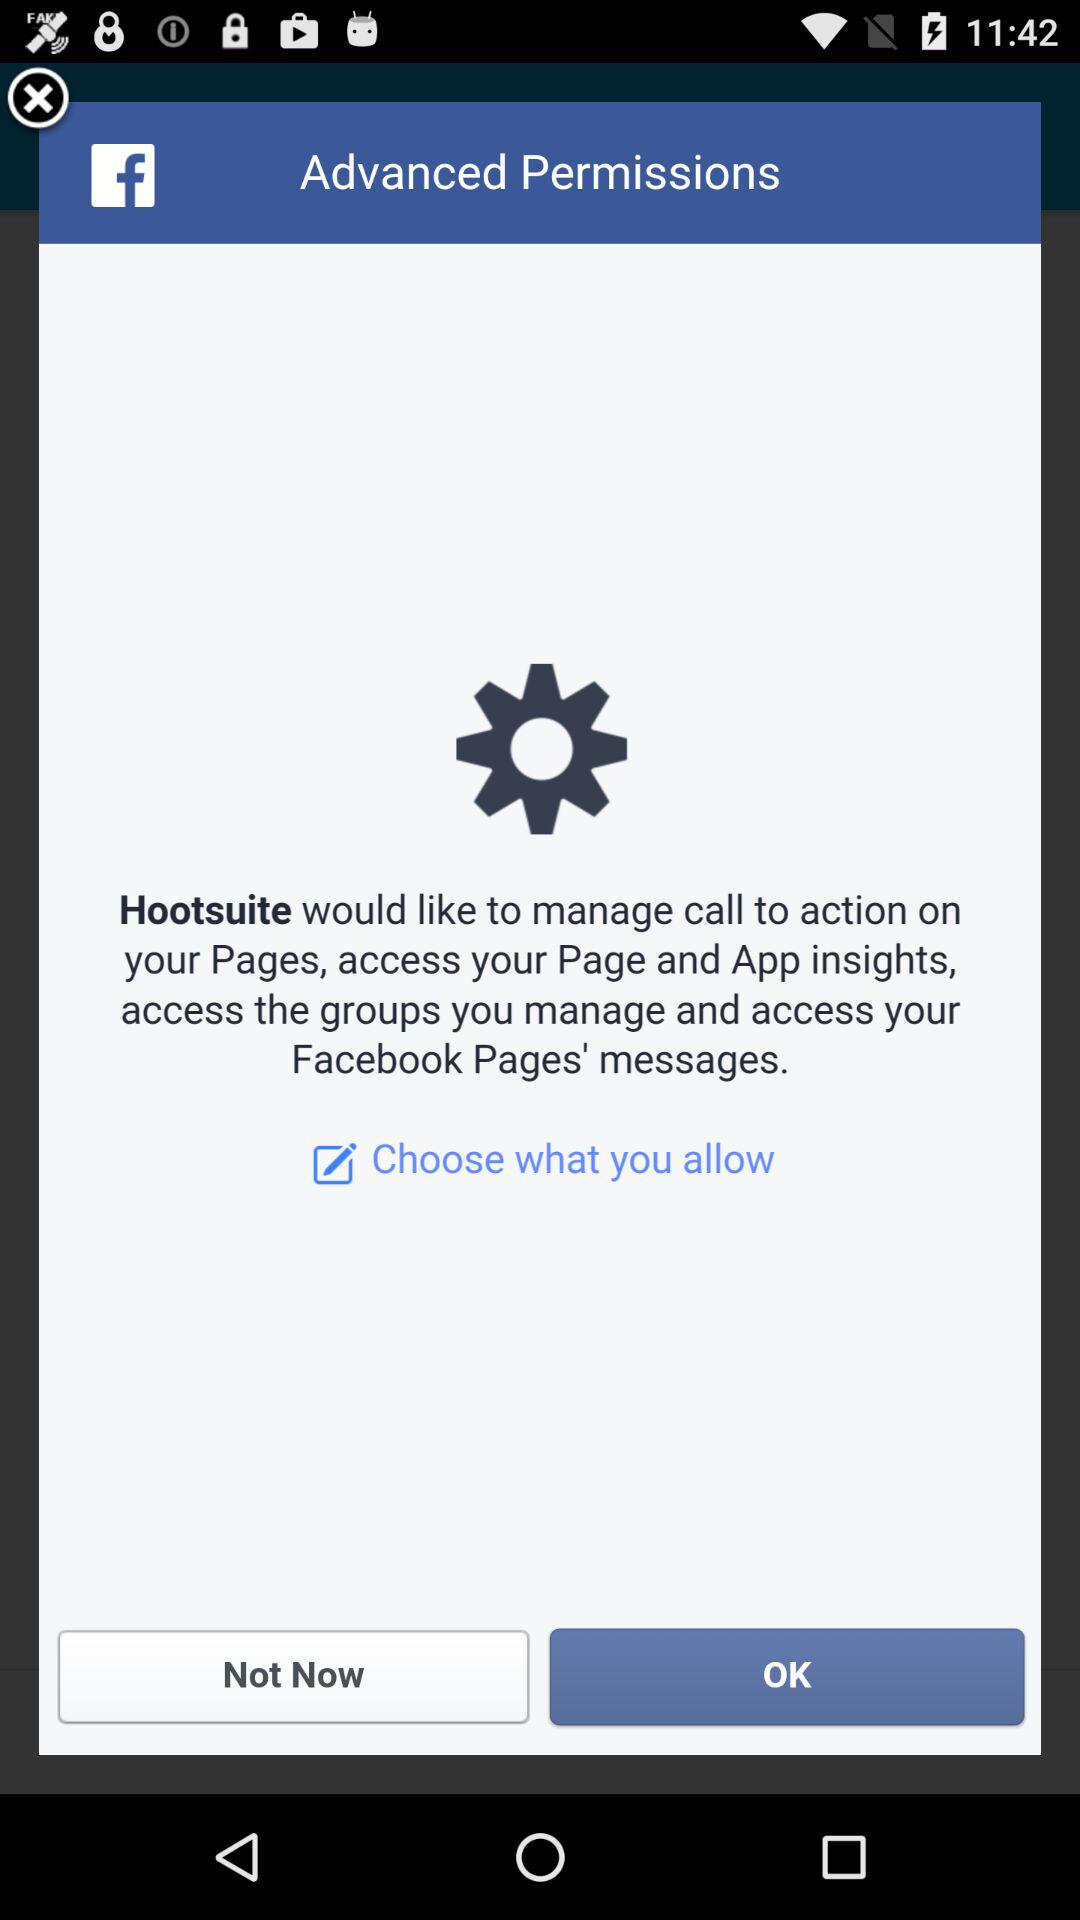What application would like to manage calls to action on your pages, access your page and app insights, access the groups you manage, and access your Facebook pages' messages? The application is "Hootsuite". 